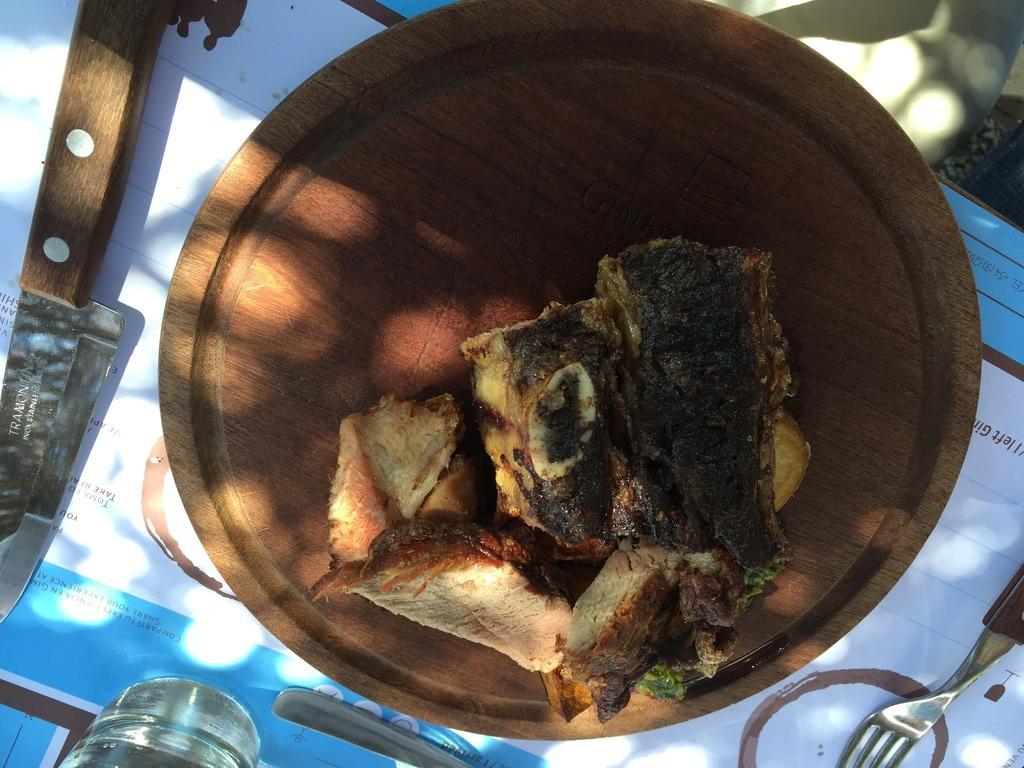Please provide a concise description of this image. This image consists of meat kept on a plate. On the left, there is a knife's. On the right, there is a fork. At the bottom, we can see a glass. This plate is kept on a table, on which there are menu cards. 